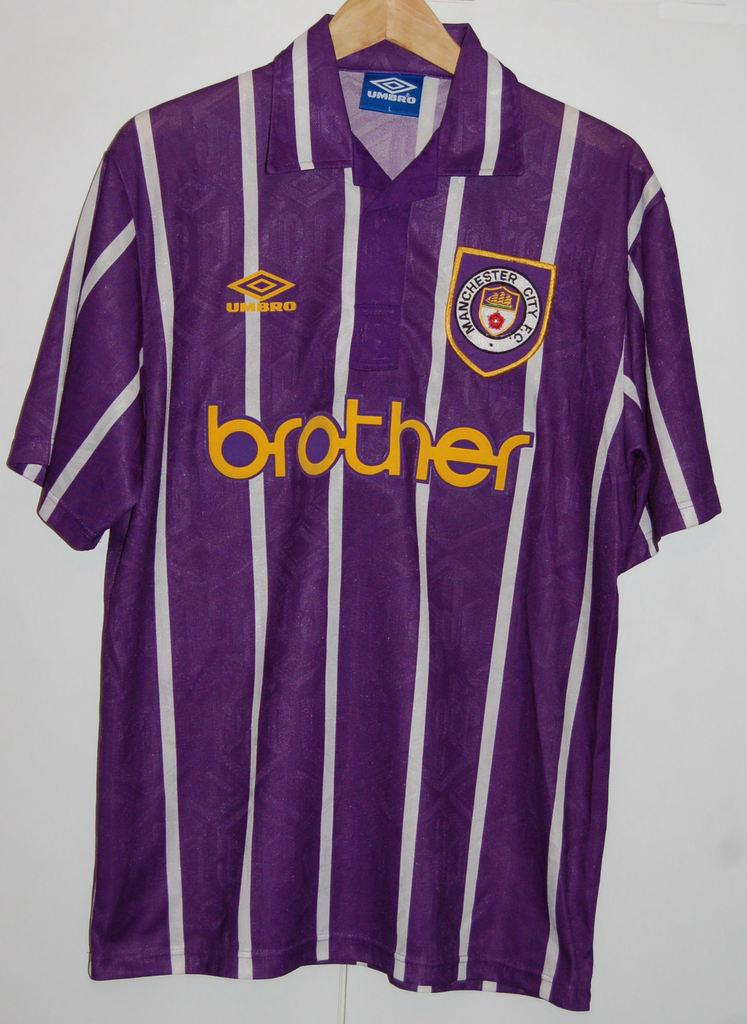What type of clothing item is in the image? There is a t-shirt in the image. How is the t-shirt positioned in the image? The t-shirt is on a hanger. Can you see a snake slithering on the t-shirt in the image? No, there is no snake present in the image. 